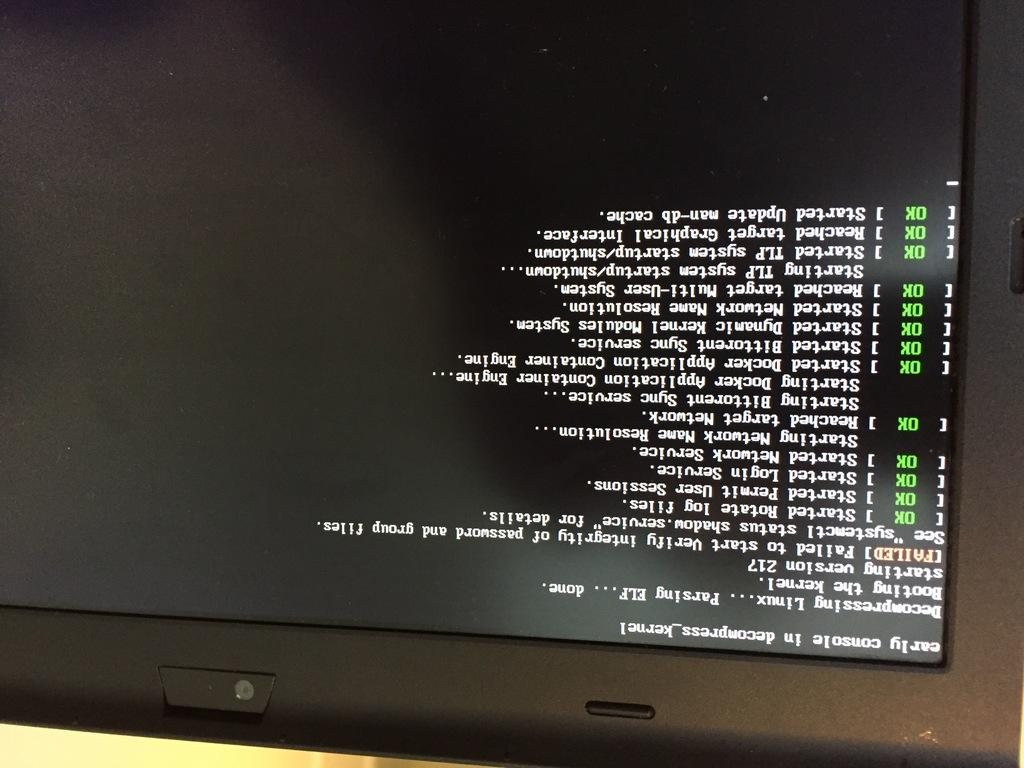Provide a one-sentence caption for the provided image. An upside down image of a computer screen which shows many successful commands and one failed command. 